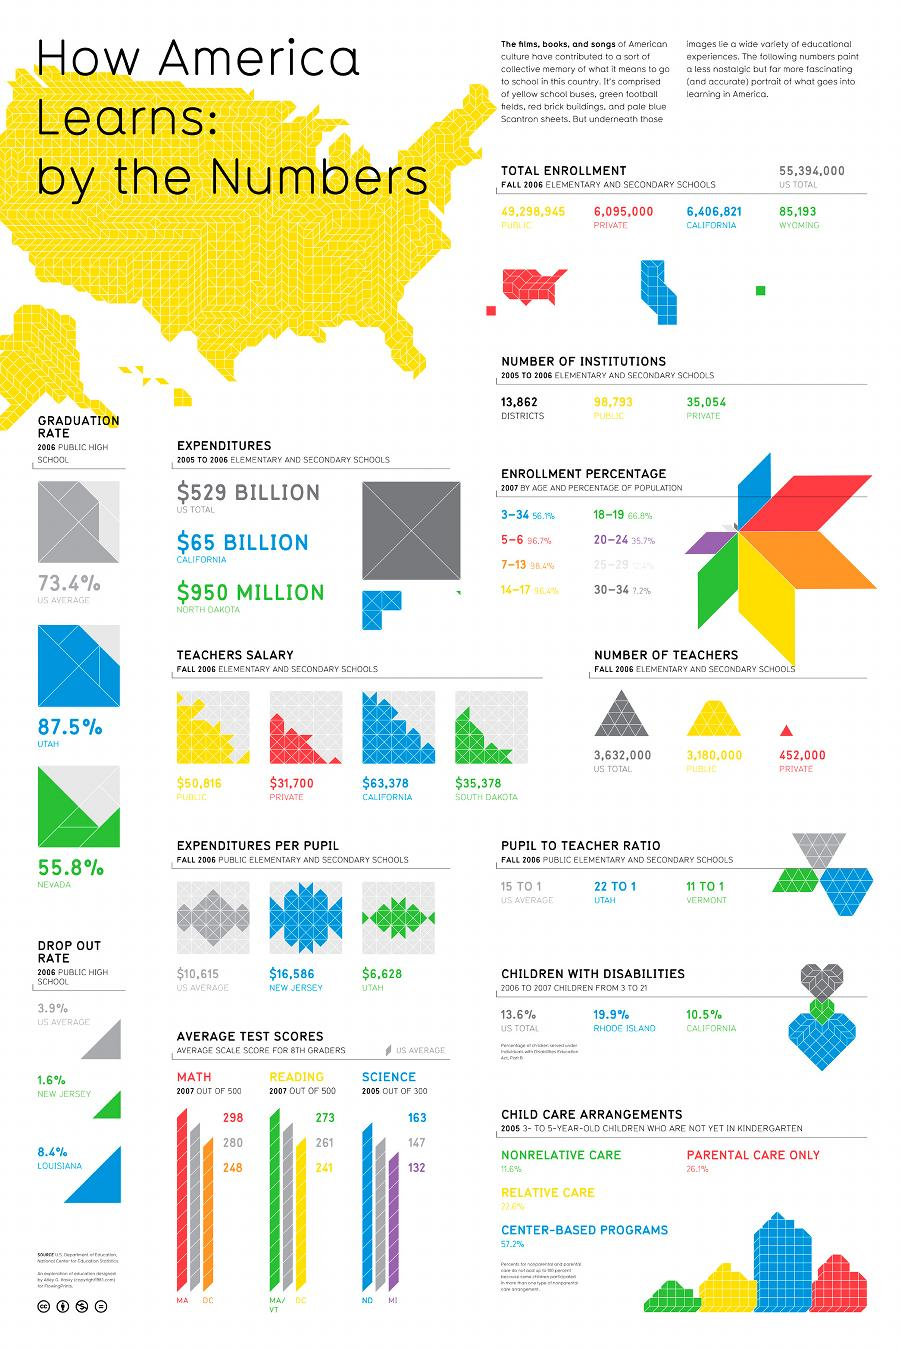Give some essential details in this illustration. In Utah, expenditure per pupil is higher than in New Jersey. In fact, in New Jersey, expenditure per pupil is lower than in Utah. The total number of enrollment is higher in the public sector compared to the private sector. According to the drop out rate of 2006, New Jersey and Louisiana were found to have the highest rates among all regions. The drop out rate of 2006 in Louisiana was found to be the highest. The average science score of US 8th graders out of 500 in 2007 was 147. In New Jersey, the dropout rate in 2006 was lower than the national average in the United States. 